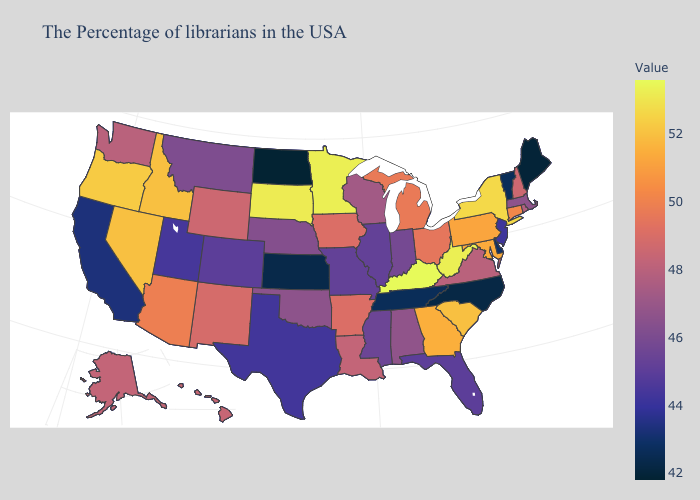Does Indiana have a lower value than Tennessee?
Write a very short answer. No. Which states have the lowest value in the USA?
Concise answer only. North Dakota. Does the map have missing data?
Give a very brief answer. No. 